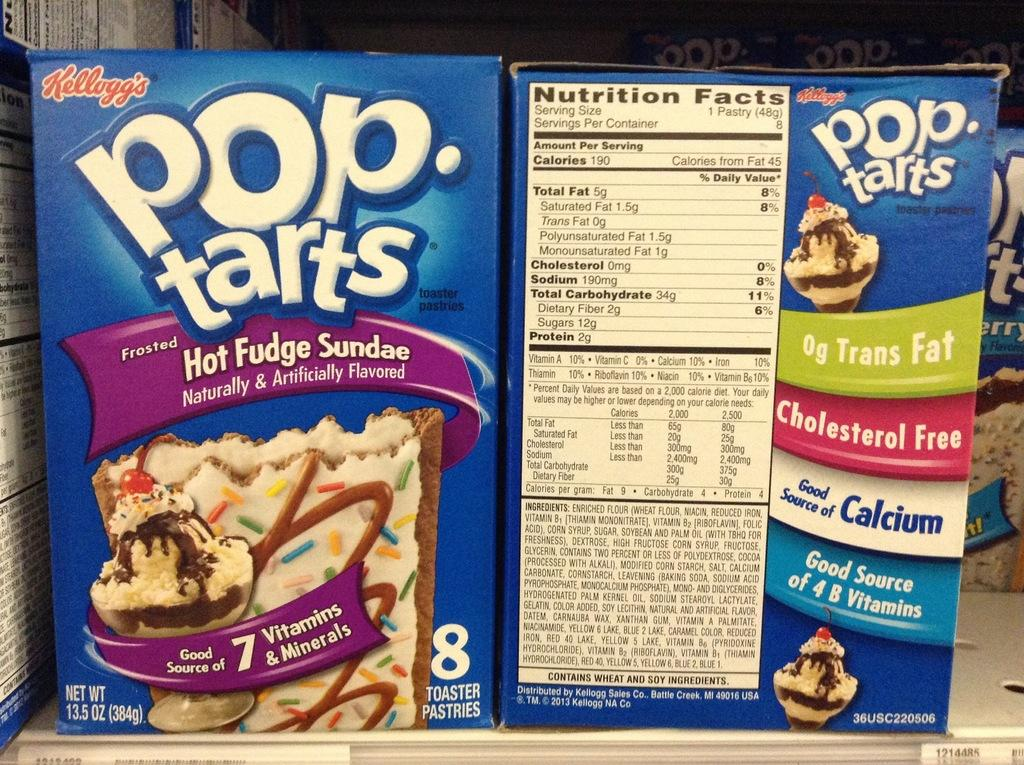What is located in the middle of the image? There are boxes with images and text in the middle of the image. What is at the bottom of the image? There is a shelf at the bottom of the image. Are there any additional items on the shelf? Yes, there are two stickers on the shelf. What type of zipper can be seen on the boxes in the image? There is no zipper present on the boxes in the image. What property is being advertised on the stickers in the image? There is no information about a property on the stickers in the image. 